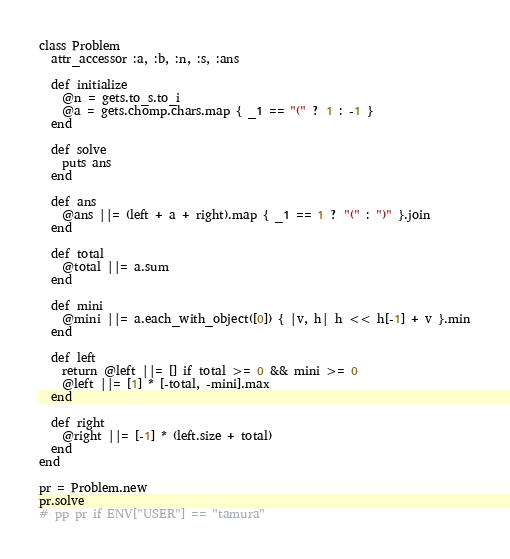Convert code to text. <code><loc_0><loc_0><loc_500><loc_500><_Ruby_>class Problem
  attr_accessor :a, :b, :n, :s, :ans

  def initialize
    @n = gets.to_s.to_i
    @a = gets.chomp.chars.map { _1 == "(" ? 1 : -1 }
  end

  def solve
    puts ans
  end

  def ans
    @ans ||= (left + a + right).map { _1 == 1 ? "(" : ")" }.join
  end

  def total
    @total ||= a.sum
  end

  def mini
    @mini ||= a.each_with_object([0]) { |v, h| h << h[-1] + v }.min
  end

  def left
    return @left ||= [] if total >= 0 && mini >= 0
    @left ||= [1] * [-total, -mini].max
  end

  def right
    @right ||= [-1] * (left.size + total)
  end
end

pr = Problem.new
pr.solve
# pp pr if ENV["USER"] == "tamura"</code> 